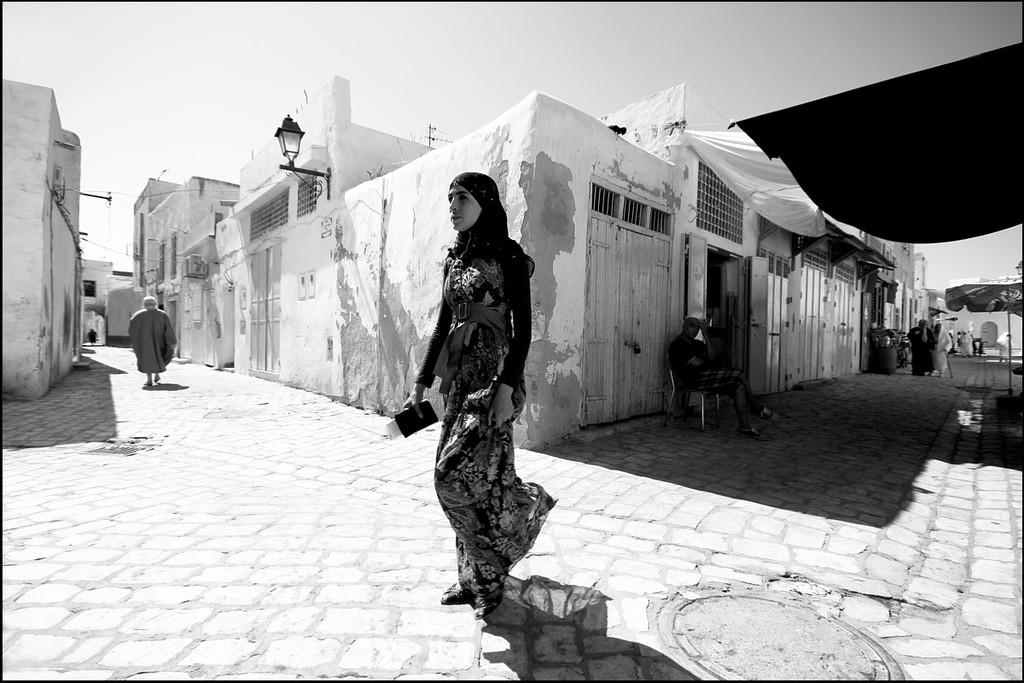Who is the main subject in the image? There is a woman in the image. What is the woman doing in the image? The woman is walking on the ground. What can be seen in the background of the image? There are buildings, people, and the sky visible in the background of the image. What type of pan is the woman using to cook in the image? There is no pan present in the image; the woman is walking on the ground. What kind of joke is being told by the people in the background of the image? There is no indication of a joke being told in the image; it only shows people in the background. 